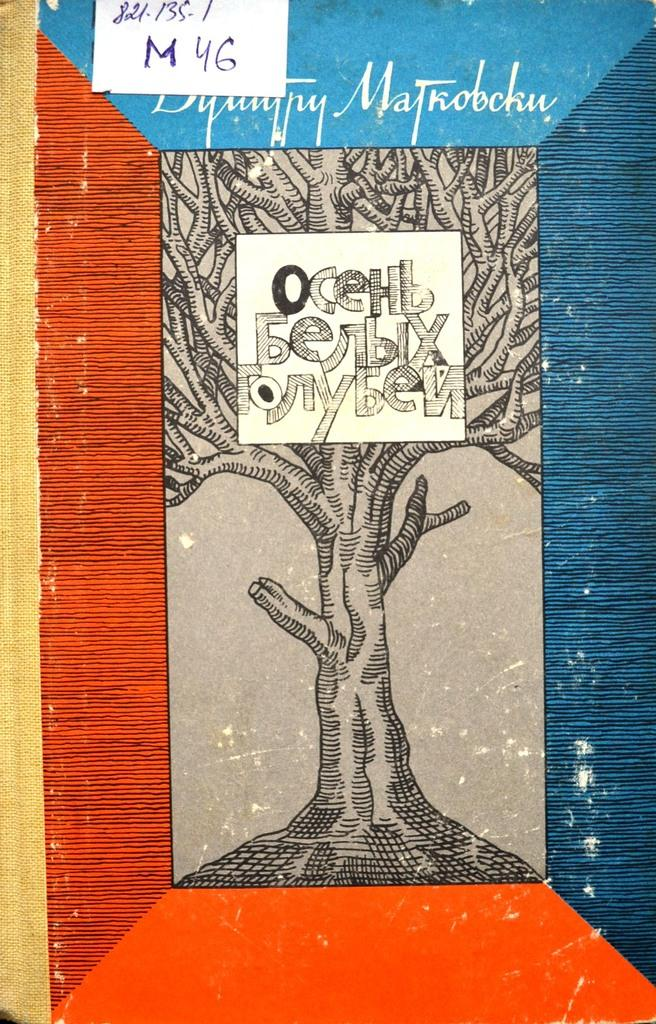What is the main subject of the image? There is a depiction of a tree in the image. How many white-colored things can be seen in the image? There are two white-colored things in the image. What is written on the white-colored things? Something is written on the white-colored things. What type of operation is being performed on the tree in the image? There is no operation being performed on the tree in the image; it is a depiction of a tree. Can you tell me how the sun is affecting the tree in the image? The image does not show the sun or its effect on the tree. 